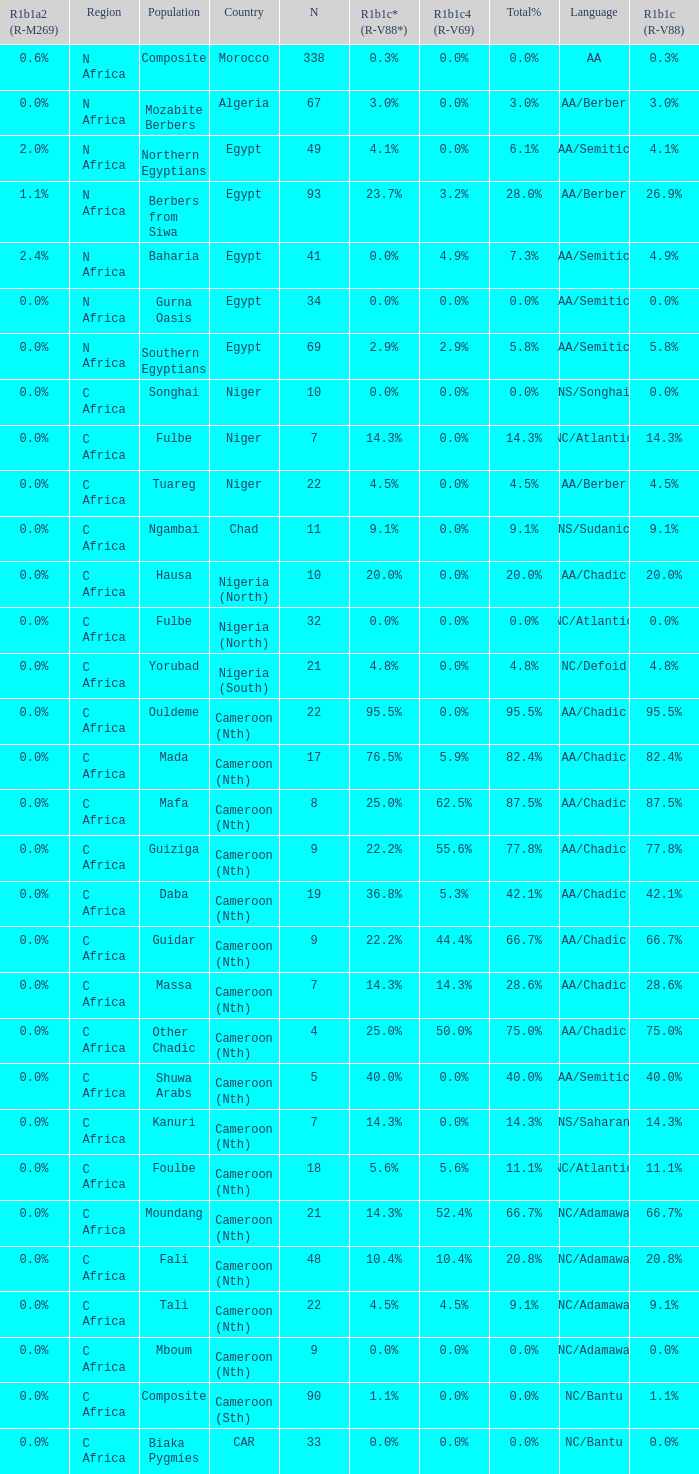What languages are spoken in Niger with r1b1c (r-v88) of 0.0%? NS/Songhai. Parse the table in full. {'header': ['R1b1a2 (R-M269)', 'Region', 'Population', 'Country', 'N', 'R1b1c* (R-V88*)', 'R1b1c4 (R-V69)', 'Total%', 'Language', 'R1b1c (R-V88)'], 'rows': [['0.6%', 'N Africa', 'Composite', 'Morocco', '338', '0.3%', '0.0%', '0.0%', 'AA', '0.3%'], ['0.0%', 'N Africa', 'Mozabite Berbers', 'Algeria', '67', '3.0%', '0.0%', '3.0%', 'AA/Berber', '3.0%'], ['2.0%', 'N Africa', 'Northern Egyptians', 'Egypt', '49', '4.1%', '0.0%', '6.1%', 'AA/Semitic', '4.1%'], ['1.1%', 'N Africa', 'Berbers from Siwa', 'Egypt', '93', '23.7%', '3.2%', '28.0%', 'AA/Berber', '26.9%'], ['2.4%', 'N Africa', 'Baharia', 'Egypt', '41', '0.0%', '4.9%', '7.3%', 'AA/Semitic', '4.9%'], ['0.0%', 'N Africa', 'Gurna Oasis', 'Egypt', '34', '0.0%', '0.0%', '0.0%', 'AA/Semitic', '0.0%'], ['0.0%', 'N Africa', 'Southern Egyptians', 'Egypt', '69', '2.9%', '2.9%', '5.8%', 'AA/Semitic', '5.8%'], ['0.0%', 'C Africa', 'Songhai', 'Niger', '10', '0.0%', '0.0%', '0.0%', 'NS/Songhai', '0.0%'], ['0.0%', 'C Africa', 'Fulbe', 'Niger', '7', '14.3%', '0.0%', '14.3%', 'NC/Atlantic', '14.3%'], ['0.0%', 'C Africa', 'Tuareg', 'Niger', '22', '4.5%', '0.0%', '4.5%', 'AA/Berber', '4.5%'], ['0.0%', 'C Africa', 'Ngambai', 'Chad', '11', '9.1%', '0.0%', '9.1%', 'NS/Sudanic', '9.1%'], ['0.0%', 'C Africa', 'Hausa', 'Nigeria (North)', '10', '20.0%', '0.0%', '20.0%', 'AA/Chadic', '20.0%'], ['0.0%', 'C Africa', 'Fulbe', 'Nigeria (North)', '32', '0.0%', '0.0%', '0.0%', 'NC/Atlantic', '0.0%'], ['0.0%', 'C Africa', 'Yorubad', 'Nigeria (South)', '21', '4.8%', '0.0%', '4.8%', 'NC/Defoid', '4.8%'], ['0.0%', 'C Africa', 'Ouldeme', 'Cameroon (Nth)', '22', '95.5%', '0.0%', '95.5%', 'AA/Chadic', '95.5%'], ['0.0%', 'C Africa', 'Mada', 'Cameroon (Nth)', '17', '76.5%', '5.9%', '82.4%', 'AA/Chadic', '82.4%'], ['0.0%', 'C Africa', 'Mafa', 'Cameroon (Nth)', '8', '25.0%', '62.5%', '87.5%', 'AA/Chadic', '87.5%'], ['0.0%', 'C Africa', 'Guiziga', 'Cameroon (Nth)', '9', '22.2%', '55.6%', '77.8%', 'AA/Chadic', '77.8%'], ['0.0%', 'C Africa', 'Daba', 'Cameroon (Nth)', '19', '36.8%', '5.3%', '42.1%', 'AA/Chadic', '42.1%'], ['0.0%', 'C Africa', 'Guidar', 'Cameroon (Nth)', '9', '22.2%', '44.4%', '66.7%', 'AA/Chadic', '66.7%'], ['0.0%', 'C Africa', 'Massa', 'Cameroon (Nth)', '7', '14.3%', '14.3%', '28.6%', 'AA/Chadic', '28.6%'], ['0.0%', 'C Africa', 'Other Chadic', 'Cameroon (Nth)', '4', '25.0%', '50.0%', '75.0%', 'AA/Chadic', '75.0%'], ['0.0%', 'C Africa', 'Shuwa Arabs', 'Cameroon (Nth)', '5', '40.0%', '0.0%', '40.0%', 'AA/Semitic', '40.0%'], ['0.0%', 'C Africa', 'Kanuri', 'Cameroon (Nth)', '7', '14.3%', '0.0%', '14.3%', 'NS/Saharan', '14.3%'], ['0.0%', 'C Africa', 'Foulbe', 'Cameroon (Nth)', '18', '5.6%', '5.6%', '11.1%', 'NC/Atlantic', '11.1%'], ['0.0%', 'C Africa', 'Moundang', 'Cameroon (Nth)', '21', '14.3%', '52.4%', '66.7%', 'NC/Adamawa', '66.7%'], ['0.0%', 'C Africa', 'Fali', 'Cameroon (Nth)', '48', '10.4%', '10.4%', '20.8%', 'NC/Adamawa', '20.8%'], ['0.0%', 'C Africa', 'Tali', 'Cameroon (Nth)', '22', '4.5%', '4.5%', '9.1%', 'NC/Adamawa', '9.1%'], ['0.0%', 'C Africa', 'Mboum', 'Cameroon (Nth)', '9', '0.0%', '0.0%', '0.0%', 'NC/Adamawa', '0.0%'], ['0.0%', 'C Africa', 'Composite', 'Cameroon (Sth)', '90', '1.1%', '0.0%', '0.0%', 'NC/Bantu', '1.1%'], ['0.0%', 'C Africa', 'Biaka Pygmies', 'CAR', '33', '0.0%', '0.0%', '0.0%', 'NC/Bantu', '0.0%']]} 